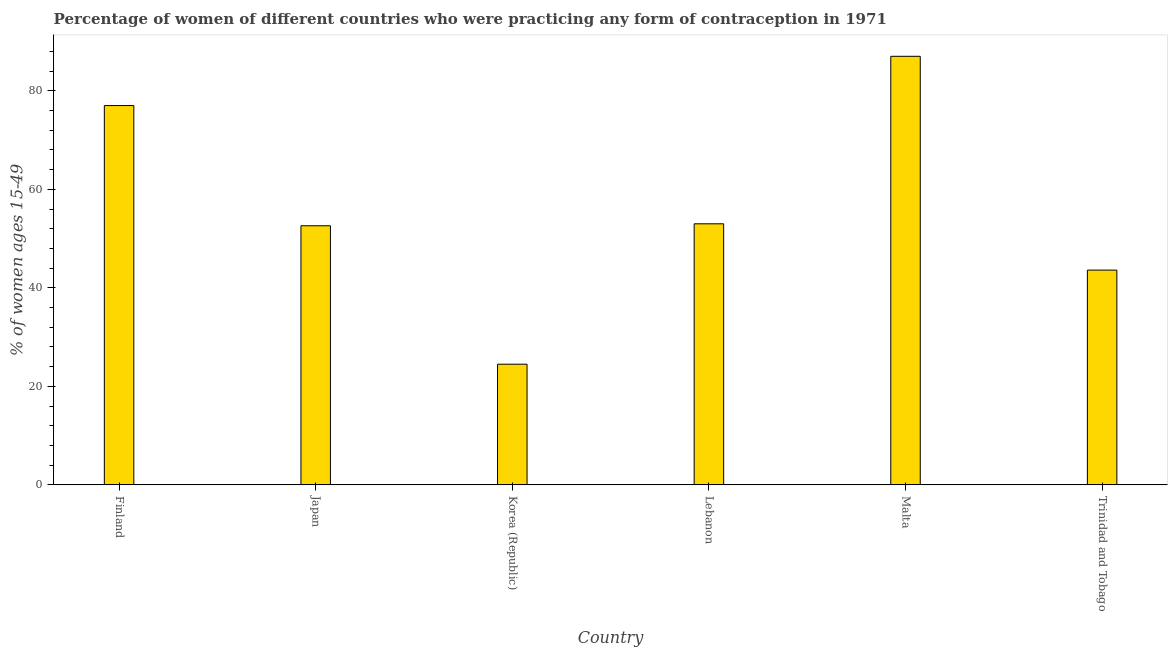Does the graph contain grids?
Make the answer very short. No. What is the title of the graph?
Your answer should be very brief. Percentage of women of different countries who were practicing any form of contraception in 1971. What is the label or title of the X-axis?
Offer a very short reply. Country. What is the label or title of the Y-axis?
Your answer should be compact. % of women ages 15-49. What is the contraceptive prevalence in Korea (Republic)?
Offer a terse response. 24.5. Across all countries, what is the minimum contraceptive prevalence?
Your answer should be very brief. 24.5. In which country was the contraceptive prevalence maximum?
Keep it short and to the point. Malta. What is the sum of the contraceptive prevalence?
Keep it short and to the point. 337.7. What is the difference between the contraceptive prevalence in Finland and Lebanon?
Give a very brief answer. 24. What is the average contraceptive prevalence per country?
Offer a very short reply. 56.28. What is the median contraceptive prevalence?
Make the answer very short. 52.8. In how many countries, is the contraceptive prevalence greater than 80 %?
Provide a short and direct response. 1. Is the sum of the contraceptive prevalence in Finland and Trinidad and Tobago greater than the maximum contraceptive prevalence across all countries?
Provide a succinct answer. Yes. What is the difference between the highest and the lowest contraceptive prevalence?
Provide a succinct answer. 62.5. In how many countries, is the contraceptive prevalence greater than the average contraceptive prevalence taken over all countries?
Offer a very short reply. 2. Are all the bars in the graph horizontal?
Your answer should be very brief. No. How many countries are there in the graph?
Provide a short and direct response. 6. What is the difference between two consecutive major ticks on the Y-axis?
Provide a short and direct response. 20. What is the % of women ages 15-49 of Finland?
Make the answer very short. 77. What is the % of women ages 15-49 in Japan?
Give a very brief answer. 52.6. What is the % of women ages 15-49 in Korea (Republic)?
Your response must be concise. 24.5. What is the % of women ages 15-49 of Lebanon?
Your answer should be compact. 53. What is the % of women ages 15-49 of Trinidad and Tobago?
Your answer should be compact. 43.6. What is the difference between the % of women ages 15-49 in Finland and Japan?
Ensure brevity in your answer.  24.4. What is the difference between the % of women ages 15-49 in Finland and Korea (Republic)?
Your answer should be compact. 52.5. What is the difference between the % of women ages 15-49 in Finland and Lebanon?
Provide a succinct answer. 24. What is the difference between the % of women ages 15-49 in Finland and Trinidad and Tobago?
Provide a short and direct response. 33.4. What is the difference between the % of women ages 15-49 in Japan and Korea (Republic)?
Give a very brief answer. 28.1. What is the difference between the % of women ages 15-49 in Japan and Malta?
Provide a short and direct response. -34.4. What is the difference between the % of women ages 15-49 in Japan and Trinidad and Tobago?
Your response must be concise. 9. What is the difference between the % of women ages 15-49 in Korea (Republic) and Lebanon?
Provide a short and direct response. -28.5. What is the difference between the % of women ages 15-49 in Korea (Republic) and Malta?
Make the answer very short. -62.5. What is the difference between the % of women ages 15-49 in Korea (Republic) and Trinidad and Tobago?
Ensure brevity in your answer.  -19.1. What is the difference between the % of women ages 15-49 in Lebanon and Malta?
Offer a terse response. -34. What is the difference between the % of women ages 15-49 in Malta and Trinidad and Tobago?
Ensure brevity in your answer.  43.4. What is the ratio of the % of women ages 15-49 in Finland to that in Japan?
Make the answer very short. 1.46. What is the ratio of the % of women ages 15-49 in Finland to that in Korea (Republic)?
Keep it short and to the point. 3.14. What is the ratio of the % of women ages 15-49 in Finland to that in Lebanon?
Make the answer very short. 1.45. What is the ratio of the % of women ages 15-49 in Finland to that in Malta?
Offer a terse response. 0.89. What is the ratio of the % of women ages 15-49 in Finland to that in Trinidad and Tobago?
Offer a very short reply. 1.77. What is the ratio of the % of women ages 15-49 in Japan to that in Korea (Republic)?
Your response must be concise. 2.15. What is the ratio of the % of women ages 15-49 in Japan to that in Lebanon?
Your answer should be compact. 0.99. What is the ratio of the % of women ages 15-49 in Japan to that in Malta?
Your answer should be very brief. 0.6. What is the ratio of the % of women ages 15-49 in Japan to that in Trinidad and Tobago?
Offer a terse response. 1.21. What is the ratio of the % of women ages 15-49 in Korea (Republic) to that in Lebanon?
Offer a terse response. 0.46. What is the ratio of the % of women ages 15-49 in Korea (Republic) to that in Malta?
Your response must be concise. 0.28. What is the ratio of the % of women ages 15-49 in Korea (Republic) to that in Trinidad and Tobago?
Offer a very short reply. 0.56. What is the ratio of the % of women ages 15-49 in Lebanon to that in Malta?
Ensure brevity in your answer.  0.61. What is the ratio of the % of women ages 15-49 in Lebanon to that in Trinidad and Tobago?
Your answer should be compact. 1.22. What is the ratio of the % of women ages 15-49 in Malta to that in Trinidad and Tobago?
Make the answer very short. 2. 